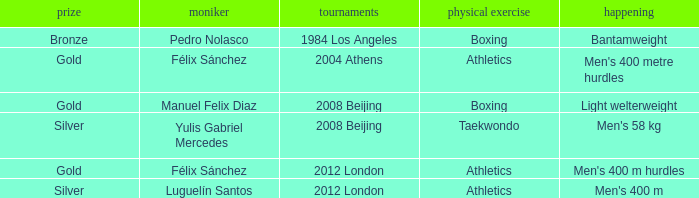Which Sport had an Event of men's 400 m hurdles? Athletics. 